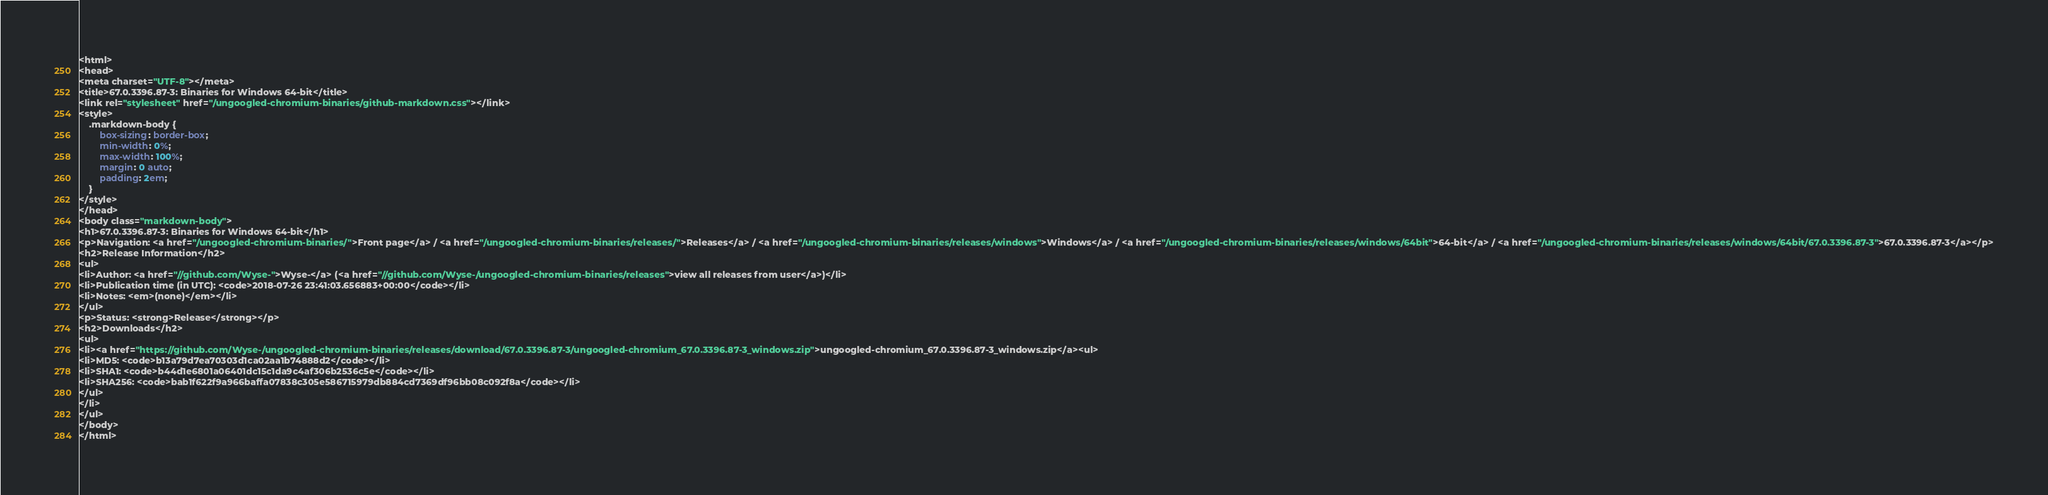Convert code to text. <code><loc_0><loc_0><loc_500><loc_500><_HTML_><html>
<head>
<meta charset="UTF-8"></meta>
<title>67.0.3396.87-3: Binaries for Windows 64-bit</title>
<link rel="stylesheet" href="/ungoogled-chromium-binaries/github-markdown.css"></link>
<style>
    .markdown-body {
        box-sizing: border-box;
        min-width: 0%;
        max-width: 100%;
        margin: 0 auto;
        padding: 2em;
    }
</style>
</head>
<body class="markdown-body">
<h1>67.0.3396.87-3: Binaries for Windows 64-bit</h1>
<p>Navigation: <a href="/ungoogled-chromium-binaries/">Front page</a> / <a href="/ungoogled-chromium-binaries/releases/">Releases</a> / <a href="/ungoogled-chromium-binaries/releases/windows">Windows</a> / <a href="/ungoogled-chromium-binaries/releases/windows/64bit">64-bit</a> / <a href="/ungoogled-chromium-binaries/releases/windows/64bit/67.0.3396.87-3">67.0.3396.87-3</a></p>
<h2>Release Information</h2>
<ul>
<li>Author: <a href="//github.com/Wyse-">Wyse-</a> (<a href="//github.com/Wyse-/ungoogled-chromium-binaries/releases">view all releases from user</a>)</li>
<li>Publication time (in UTC): <code>2018-07-26 23:41:03.656883+00:00</code></li>
<li>Notes: <em>(none)</em></li>
</ul>
<p>Status: <strong>Release</strong></p>
<h2>Downloads</h2>
<ul>
<li><a href="https://github.com/Wyse-/ungoogled-chromium-binaries/releases/download/67.0.3396.87-3/ungoogled-chromium_67.0.3396.87-3_windows.zip">ungoogled-chromium_67.0.3396.87-3_windows.zip</a><ul>
<li>MD5: <code>b13a79d7ea70303d1ca02aa1b74888d2</code></li>
<li>SHA1: <code>b44d1e6801a06401dc15c1da9c4af306b2536c5e</code></li>
<li>SHA256: <code>bab1f622f9a966baffa07838c305e586715979db884cd7369df96bb08c092f8a</code></li>
</ul>
</li>
</ul>
</body>
</html>
</code> 